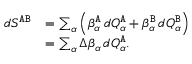<formula> <loc_0><loc_0><loc_500><loc_500>\begin{array} { r l } { d S ^ { { \tt A } { \tt B } } } & { = \sum _ { \alpha } \left ( \beta _ { \alpha } ^ { \tt A } \, d { Q } _ { \alpha } ^ { \tt A } + \beta _ { \alpha } ^ { \tt B } \, d { Q } _ { \alpha } ^ { \tt B } \right ) } \\ & { = \sum _ { \alpha } \Delta { \beta } _ { \alpha } \, d { Q } _ { \alpha } ^ { \tt A } . } \end{array}</formula> 